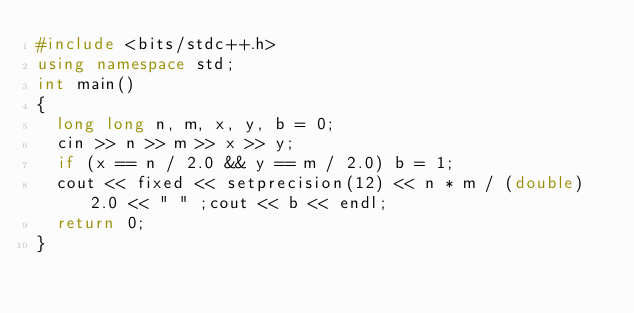<code> <loc_0><loc_0><loc_500><loc_500><_C++_>#include <bits/stdc++.h>
using namespace std;
int main()
{
	long long n, m, x, y, b = 0;
	cin >> n >> m >> x >> y;
	if (x == n / 2.0 && y == m / 2.0) b = 1;
	cout << fixed << setprecision(12) << n * m / (double)2.0 << " " ;cout << b << endl;
	return 0;
}
</code> 